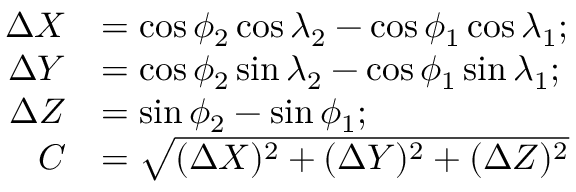Convert formula to latex. <formula><loc_0><loc_0><loc_500><loc_500>{ \begin{array} { r l } { \Delta { X } } & { = \cos \phi _ { 2 } \cos \lambda _ { 2 } - \cos \phi _ { 1 } \cos \lambda _ { 1 } ; } \\ { \Delta { Y } } & { = \cos \phi _ { 2 } \sin \lambda _ { 2 } - \cos \phi _ { 1 } \sin \lambda _ { 1 } ; } \\ { \Delta { Z } } & { = \sin \phi _ { 2 } - \sin \phi _ { 1 } ; } \\ { C } & { = { \sqrt { ( \Delta { X } ) ^ { 2 } + ( \Delta { Y } ) ^ { 2 } + ( \Delta { Z } ) ^ { 2 } } } } \end{array} }</formula> 